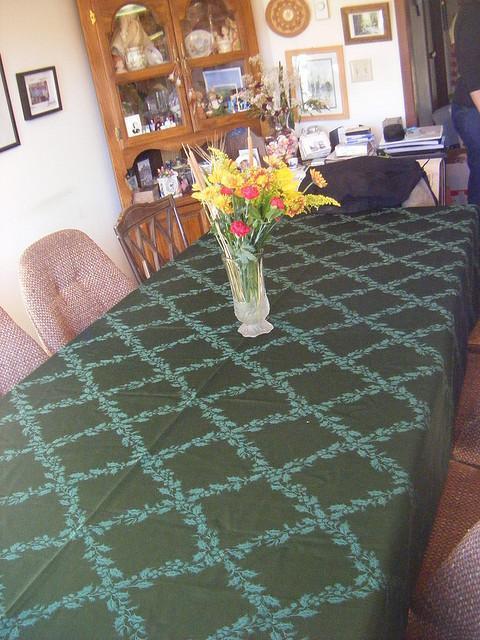How many shades of green in the tablecloth?
Give a very brief answer. 2. How many chairs are there?
Give a very brief answer. 6. How many beds are under the lamp?
Give a very brief answer. 0. 